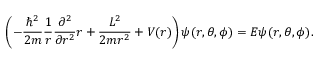<formula> <loc_0><loc_0><loc_500><loc_500>\left ( - \frac { \hbar { ^ } { 2 } } { 2 m } \frac { 1 } { r } \frac { \partial ^ { 2 } } { \partial r ^ { 2 } } r + \frac { L ^ { 2 } } { 2 m r ^ { 2 } } + V ( r ) \right ) \psi ( r , \theta , \phi ) = E \psi ( r , \theta , \phi ) .</formula> 